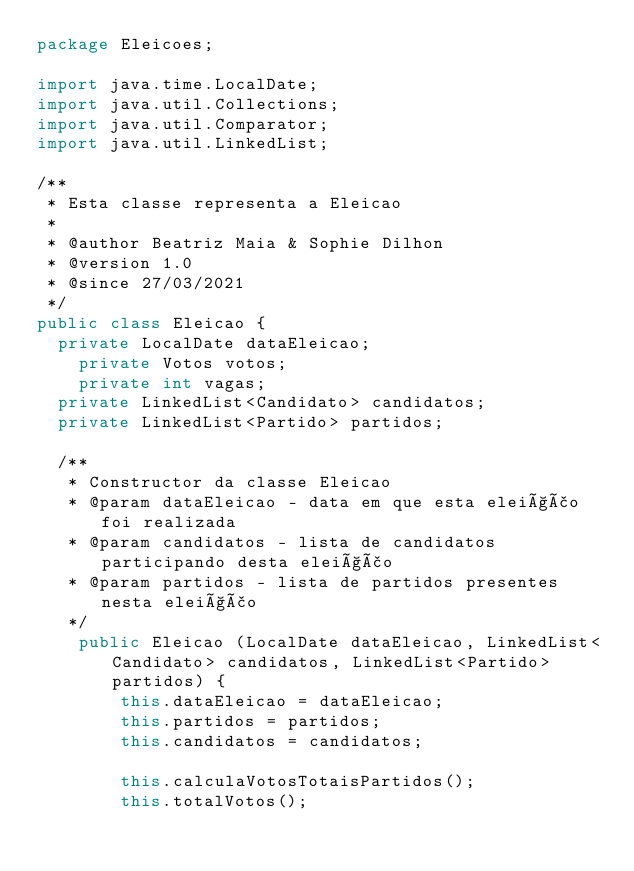Convert code to text. <code><loc_0><loc_0><loc_500><loc_500><_Java_>package Eleicoes;

import java.time.LocalDate;
import java.util.Collections;
import java.util.Comparator;
import java.util.LinkedList;

/**
 * Esta classe representa a Eleicao
 * 
 * @author Beatriz Maia & Sophie Dilhon
 * @version 1.0
 * @since 27/03/2021
 */
public class Eleicao {
	private LocalDate dataEleicao;
    private Votos votos;
    private int vagas;
	private LinkedList<Candidato> candidatos;
	private LinkedList<Partido> partidos; 

	/**
	 * Constructor da classe Eleicao
	 * @param dataEleicao - data em que esta eleição foi realizada
	 * @param candidatos - lista de candidatos participando desta eleição
	 * @param partidos - lista de partidos presentes nesta eleição
	 */
    public Eleicao (LocalDate dataEleicao, LinkedList<Candidato> candidatos, LinkedList<Partido> partidos) {
        this.dataEleicao = dataEleicao;
        this.partidos = partidos;
        this.candidatos = candidatos;
        
        this.calculaVotosTotaisPartidos();
        this.totalVotos();</code> 